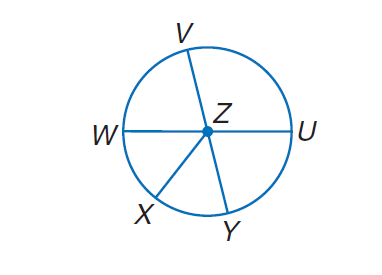Answer the mathemtical geometry problem and directly provide the correct option letter.
Question: In \odot Z, \angle W Z X \cong \angle X Z Y, m \angle V Z U = 4 x, m \angle U Z Y = 2 x + 24, and V Y and W U are diameters. Find m \widehat W V.
Choices: A: 14 B: 24 C: 76 D: 104 C 